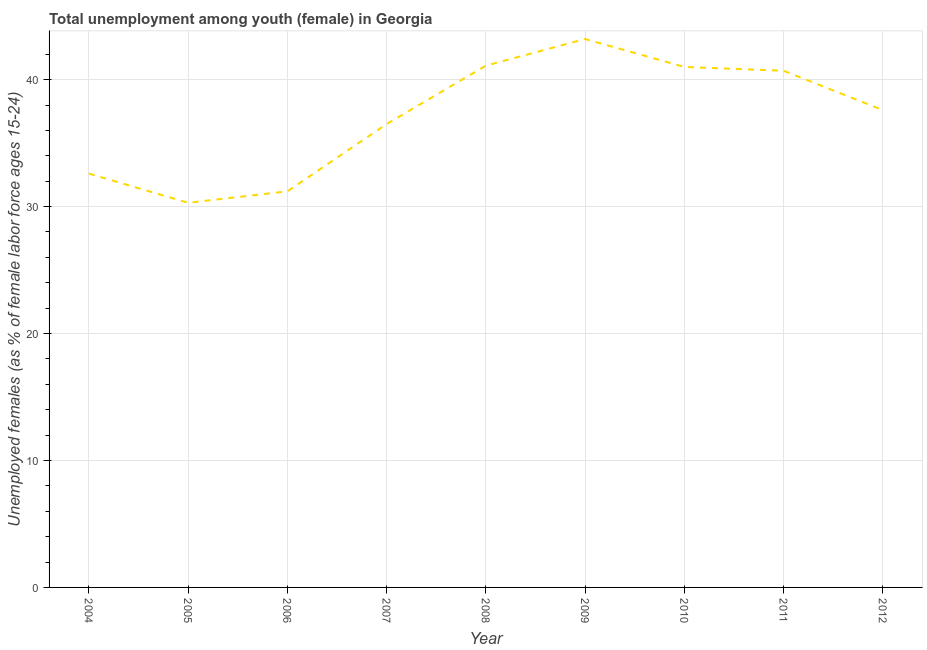What is the unemployed female youth population in 2007?
Offer a terse response. 36.5. Across all years, what is the maximum unemployed female youth population?
Keep it short and to the point. 43.2. Across all years, what is the minimum unemployed female youth population?
Keep it short and to the point. 30.3. What is the sum of the unemployed female youth population?
Make the answer very short. 334.2. What is the difference between the unemployed female youth population in 2006 and 2011?
Offer a terse response. -9.5. What is the average unemployed female youth population per year?
Make the answer very short. 37.13. What is the median unemployed female youth population?
Provide a succinct answer. 37.6. In how many years, is the unemployed female youth population greater than 22 %?
Provide a succinct answer. 9. What is the ratio of the unemployed female youth population in 2004 to that in 2010?
Offer a very short reply. 0.8. Is the unemployed female youth population in 2010 less than that in 2011?
Your answer should be very brief. No. What is the difference between the highest and the second highest unemployed female youth population?
Offer a very short reply. 2.1. What is the difference between the highest and the lowest unemployed female youth population?
Ensure brevity in your answer.  12.9. How many lines are there?
Keep it short and to the point. 1. Does the graph contain any zero values?
Your response must be concise. No. Does the graph contain grids?
Your response must be concise. Yes. What is the title of the graph?
Give a very brief answer. Total unemployment among youth (female) in Georgia. What is the label or title of the Y-axis?
Offer a very short reply. Unemployed females (as % of female labor force ages 15-24). What is the Unemployed females (as % of female labor force ages 15-24) of 2004?
Ensure brevity in your answer.  32.6. What is the Unemployed females (as % of female labor force ages 15-24) of 2005?
Offer a terse response. 30.3. What is the Unemployed females (as % of female labor force ages 15-24) of 2006?
Offer a very short reply. 31.2. What is the Unemployed females (as % of female labor force ages 15-24) in 2007?
Provide a short and direct response. 36.5. What is the Unemployed females (as % of female labor force ages 15-24) of 2008?
Your answer should be very brief. 41.1. What is the Unemployed females (as % of female labor force ages 15-24) of 2009?
Your answer should be compact. 43.2. What is the Unemployed females (as % of female labor force ages 15-24) of 2011?
Give a very brief answer. 40.7. What is the Unemployed females (as % of female labor force ages 15-24) of 2012?
Your response must be concise. 37.6. What is the difference between the Unemployed females (as % of female labor force ages 15-24) in 2004 and 2008?
Give a very brief answer. -8.5. What is the difference between the Unemployed females (as % of female labor force ages 15-24) in 2004 and 2010?
Your response must be concise. -8.4. What is the difference between the Unemployed females (as % of female labor force ages 15-24) in 2004 and 2011?
Offer a terse response. -8.1. What is the difference between the Unemployed females (as % of female labor force ages 15-24) in 2005 and 2009?
Give a very brief answer. -12.9. What is the difference between the Unemployed females (as % of female labor force ages 15-24) in 2005 and 2011?
Provide a short and direct response. -10.4. What is the difference between the Unemployed females (as % of female labor force ages 15-24) in 2006 and 2010?
Offer a terse response. -9.8. What is the difference between the Unemployed females (as % of female labor force ages 15-24) in 2006 and 2011?
Give a very brief answer. -9.5. What is the difference between the Unemployed females (as % of female labor force ages 15-24) in 2006 and 2012?
Your response must be concise. -6.4. What is the difference between the Unemployed females (as % of female labor force ages 15-24) in 2008 and 2010?
Your answer should be very brief. 0.1. What is the difference between the Unemployed females (as % of female labor force ages 15-24) in 2008 and 2011?
Make the answer very short. 0.4. What is the difference between the Unemployed females (as % of female labor force ages 15-24) in 2008 and 2012?
Keep it short and to the point. 3.5. What is the difference between the Unemployed females (as % of female labor force ages 15-24) in 2009 and 2010?
Make the answer very short. 2.2. What is the difference between the Unemployed females (as % of female labor force ages 15-24) in 2009 and 2011?
Ensure brevity in your answer.  2.5. What is the difference between the Unemployed females (as % of female labor force ages 15-24) in 2010 and 2012?
Offer a terse response. 3.4. What is the ratio of the Unemployed females (as % of female labor force ages 15-24) in 2004 to that in 2005?
Provide a short and direct response. 1.08. What is the ratio of the Unemployed females (as % of female labor force ages 15-24) in 2004 to that in 2006?
Make the answer very short. 1.04. What is the ratio of the Unemployed females (as % of female labor force ages 15-24) in 2004 to that in 2007?
Ensure brevity in your answer.  0.89. What is the ratio of the Unemployed females (as % of female labor force ages 15-24) in 2004 to that in 2008?
Offer a very short reply. 0.79. What is the ratio of the Unemployed females (as % of female labor force ages 15-24) in 2004 to that in 2009?
Make the answer very short. 0.76. What is the ratio of the Unemployed females (as % of female labor force ages 15-24) in 2004 to that in 2010?
Offer a terse response. 0.8. What is the ratio of the Unemployed females (as % of female labor force ages 15-24) in 2004 to that in 2011?
Keep it short and to the point. 0.8. What is the ratio of the Unemployed females (as % of female labor force ages 15-24) in 2004 to that in 2012?
Give a very brief answer. 0.87. What is the ratio of the Unemployed females (as % of female labor force ages 15-24) in 2005 to that in 2006?
Make the answer very short. 0.97. What is the ratio of the Unemployed females (as % of female labor force ages 15-24) in 2005 to that in 2007?
Ensure brevity in your answer.  0.83. What is the ratio of the Unemployed females (as % of female labor force ages 15-24) in 2005 to that in 2008?
Offer a terse response. 0.74. What is the ratio of the Unemployed females (as % of female labor force ages 15-24) in 2005 to that in 2009?
Give a very brief answer. 0.7. What is the ratio of the Unemployed females (as % of female labor force ages 15-24) in 2005 to that in 2010?
Offer a very short reply. 0.74. What is the ratio of the Unemployed females (as % of female labor force ages 15-24) in 2005 to that in 2011?
Keep it short and to the point. 0.74. What is the ratio of the Unemployed females (as % of female labor force ages 15-24) in 2005 to that in 2012?
Your answer should be compact. 0.81. What is the ratio of the Unemployed females (as % of female labor force ages 15-24) in 2006 to that in 2007?
Your answer should be very brief. 0.85. What is the ratio of the Unemployed females (as % of female labor force ages 15-24) in 2006 to that in 2008?
Give a very brief answer. 0.76. What is the ratio of the Unemployed females (as % of female labor force ages 15-24) in 2006 to that in 2009?
Offer a terse response. 0.72. What is the ratio of the Unemployed females (as % of female labor force ages 15-24) in 2006 to that in 2010?
Make the answer very short. 0.76. What is the ratio of the Unemployed females (as % of female labor force ages 15-24) in 2006 to that in 2011?
Offer a very short reply. 0.77. What is the ratio of the Unemployed females (as % of female labor force ages 15-24) in 2006 to that in 2012?
Your answer should be compact. 0.83. What is the ratio of the Unemployed females (as % of female labor force ages 15-24) in 2007 to that in 2008?
Your answer should be very brief. 0.89. What is the ratio of the Unemployed females (as % of female labor force ages 15-24) in 2007 to that in 2009?
Your answer should be very brief. 0.84. What is the ratio of the Unemployed females (as % of female labor force ages 15-24) in 2007 to that in 2010?
Your response must be concise. 0.89. What is the ratio of the Unemployed females (as % of female labor force ages 15-24) in 2007 to that in 2011?
Ensure brevity in your answer.  0.9. What is the ratio of the Unemployed females (as % of female labor force ages 15-24) in 2007 to that in 2012?
Your response must be concise. 0.97. What is the ratio of the Unemployed females (as % of female labor force ages 15-24) in 2008 to that in 2009?
Keep it short and to the point. 0.95. What is the ratio of the Unemployed females (as % of female labor force ages 15-24) in 2008 to that in 2010?
Offer a very short reply. 1. What is the ratio of the Unemployed females (as % of female labor force ages 15-24) in 2008 to that in 2012?
Ensure brevity in your answer.  1.09. What is the ratio of the Unemployed females (as % of female labor force ages 15-24) in 2009 to that in 2010?
Offer a terse response. 1.05. What is the ratio of the Unemployed females (as % of female labor force ages 15-24) in 2009 to that in 2011?
Provide a short and direct response. 1.06. What is the ratio of the Unemployed females (as % of female labor force ages 15-24) in 2009 to that in 2012?
Provide a short and direct response. 1.15. What is the ratio of the Unemployed females (as % of female labor force ages 15-24) in 2010 to that in 2012?
Your response must be concise. 1.09. What is the ratio of the Unemployed females (as % of female labor force ages 15-24) in 2011 to that in 2012?
Give a very brief answer. 1.08. 